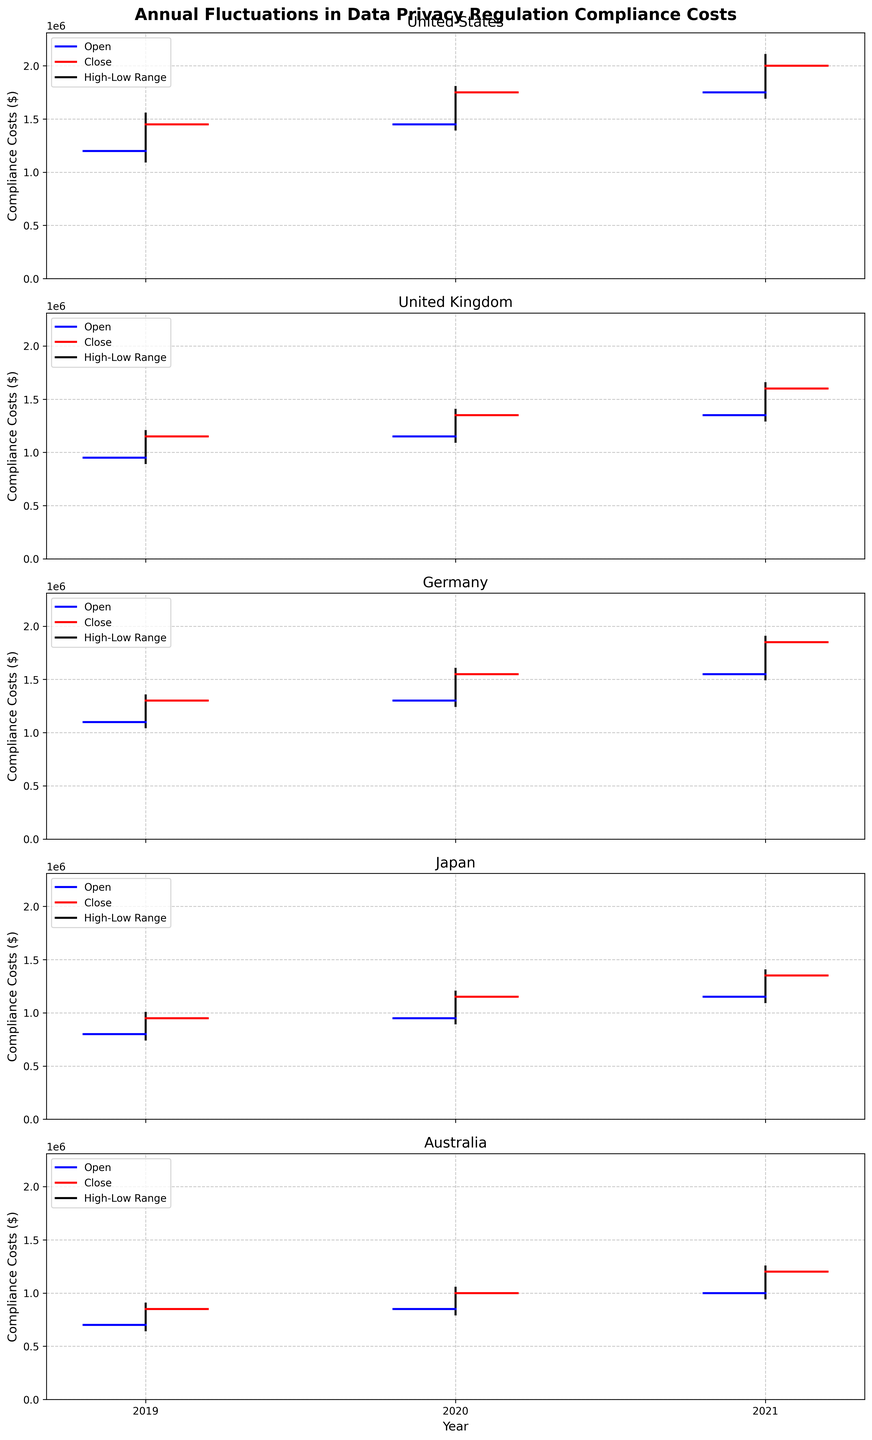What is the title of the figure? The title of the figure is mentioned at the top of the plot.
Answer: Annual Fluctuations in Data Privacy Regulation Compliance Costs What do the blue and red lines represent in the figure? The legend indicates that blue lines represent the 'Open' values and red lines represent the 'Close' values.
Answer: Open and Close values Which country saw the highest compliance cost in 2021? The 'High' value in 2021 is the highest for Germany, at 1900000.
Answer: Germany What is the range of compliance costs for the United States in 2020? The range is determined by subtracting the 'Low' value from the 'High' value for the United States in 2020: 1800000 - 1400000 = 400000.
Answer: 400000 Which country had the lowest compliance cost in 2019? By comparing the 'Low' values for each country in 2019, Australia had the lowest at 650000.
Answer: Australia How did the compliance costs trend for the United Kingdom from 2019 to 2021? The trend can be observed by looking at the 'Close' values over the years: 2019 (1150000), 2020 (1350000), and 2021 (1600000), showing an increasing trend.
Answer: Increasing Compare the 'Open' and 'Close' values for Japan in 2020. Were the costs higher at the end of the year? In 2020 for Japan, the 'Open' value is 950000 and the 'Close' value is 1150000, indicating that the costs were higher at the end of the year.
Answer: Yes What is the difference between the highest compliance costs for Germany and Australia in 2021? The difference can be calculated by subtracting the 'High' value for Australia from the 'High' value for Germany in 2021: 1900000 - 1250000 = 650000.
Answer: 650000 Did any country experience a decrease in compliance costs from 2020 to 2021? By comparing the 'Close' values between 2020 and 2021 for each country, none of them show a decrease; all saw an increase.
Answer: No 